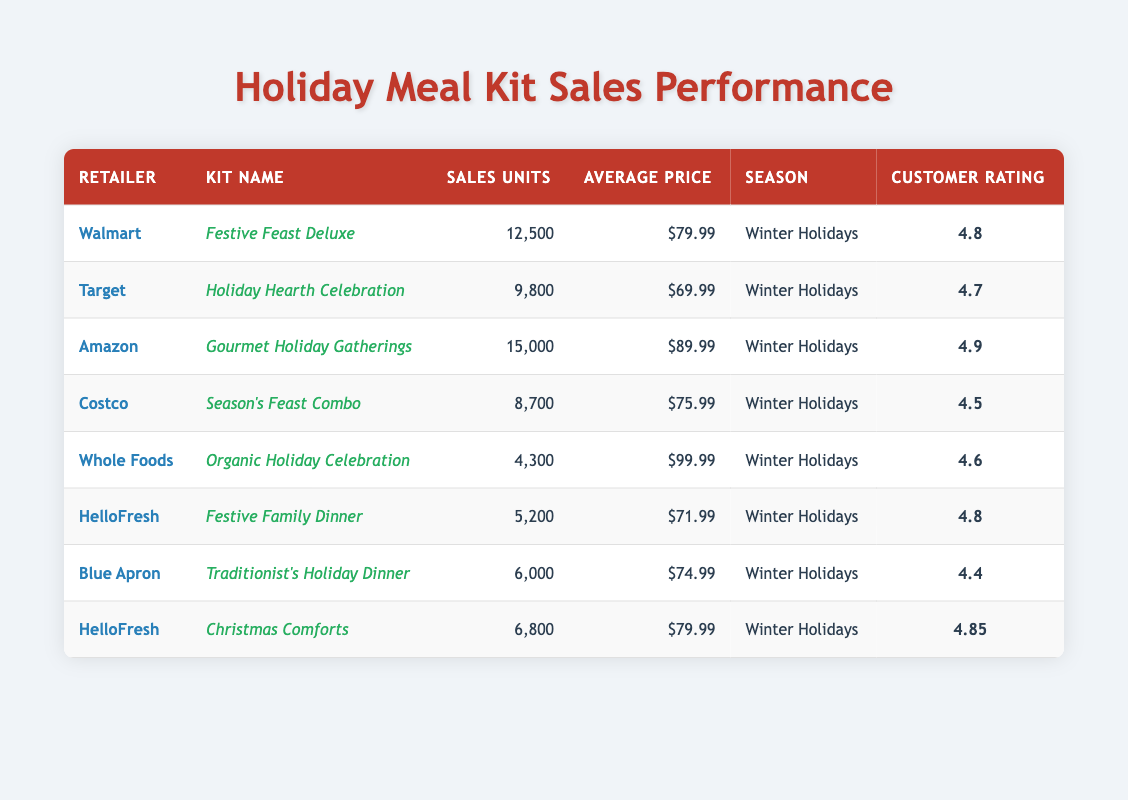What meal kit had the highest sales units? Looking through the table, the meal kit with the highest sales units is "Gourmet Holiday Gatherings" sold by Amazon, with a total of 15,000 units sold.
Answer: Gourmet Holiday Gatherings What is the average customer rating of the meal kits sold? By examining the table, the customer ratings are 4.8, 4.7, 4.9, 4.5, 4.6, 4.8, 4.4, and 4.85. To find the average, we sum these ratings: (4.8 + 4.7 + 4.9 + 4.5 + 4.6 + 4.8 + 4.4 + 4.85) = 38.55. There are 8 ratings, so the average is 38.55 / 8 = 4.81875, which can be rounded to 4.82.
Answer: 4.82 Which retailer sold the "Organic Holiday Celebration"? The table shows that "Organic Holiday Celebration" is sold by Whole Foods.
Answer: Whole Foods What is the total sales units of HelloFresh kits combined? To find the total sales units for HelloFresh, we look at the two kits: "Festive Family Dinner" with 5,200 units and "Christmas Comforts" with 6,800 units. Adding these together gives us 5,200 + 6,800 = 12,000 units.
Answer: 12,000 Is the average price of "Season's Feast Combo" higher than $70? The average price of the "Season's Feast Combo" from Costco is $75.99, which is higher than $70.
Answer: Yes Which kit has the lowest average price and what is that price? Looking through the table, the kit with the lowest average price is "Holiday Hearth Celebration" from Target at $69.99.
Answer: $69.99 Which retailer has the second highest sales units, and what are the sales units? By reviewing the sales units: Walmart has 12,500, Amazon has 15,000, Target has 9,800, Costco has 8,700, Whole Foods has 4,300, and so forth. The second highest is Walmart with 12,500 units.
Answer: Walmart, 12,500 What is the percentage difference in sales units between "Gourmet Holiday Gatherings" and "Season's Feast Combo"? "Gourmet Holiday Gatherings" sold 15,000 units and "Season's Feast Combo" sold 8,700 units. The difference is 15,000 - 8,700 = 6,300. To find the percentage difference relative to "Gourmet Holiday Gatherings": (6,300 / 15,000) * 100 = 42%.
Answer: 42% Which kit has the highest customer rating and what is that rating? Reviewing the customer ratings, the highest rating is for "Gourmet Holiday Gatherings" at 4.9.
Answer: 4.9 Between Walmart and Target, which retailer has the better average price for their meal kit? Walmart's "Festive Feast Deluxe" has an average price of $79.99, and Target's "Holiday Hearth Celebration" has an average price of $69.99. Since $69.99 is lower than $79.99, Target has the better price.
Answer: Target 